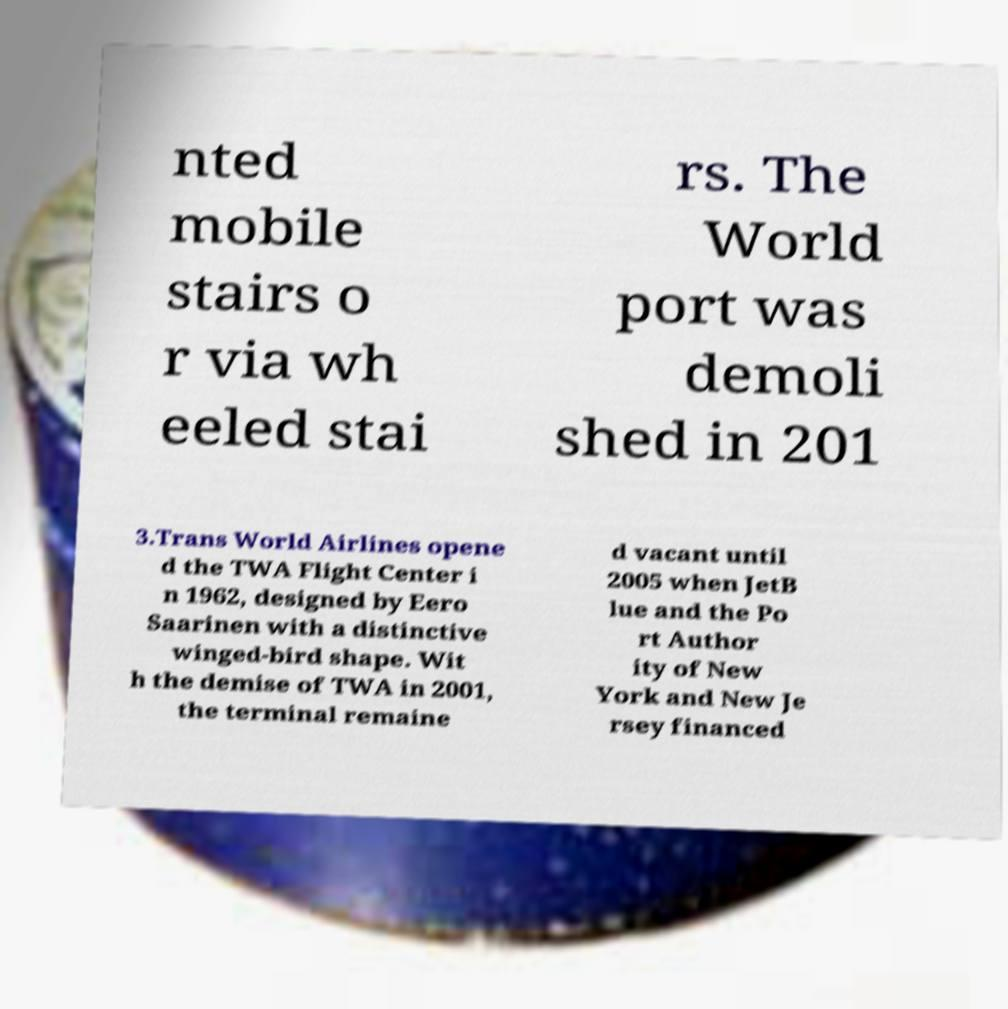What messages or text are displayed in this image? I need them in a readable, typed format. nted mobile stairs o r via wh eeled stai rs. The World port was demoli shed in 201 3.Trans World Airlines opene d the TWA Flight Center i n 1962, designed by Eero Saarinen with a distinctive winged-bird shape. Wit h the demise of TWA in 2001, the terminal remaine d vacant until 2005 when JetB lue and the Po rt Author ity of New York and New Je rsey financed 